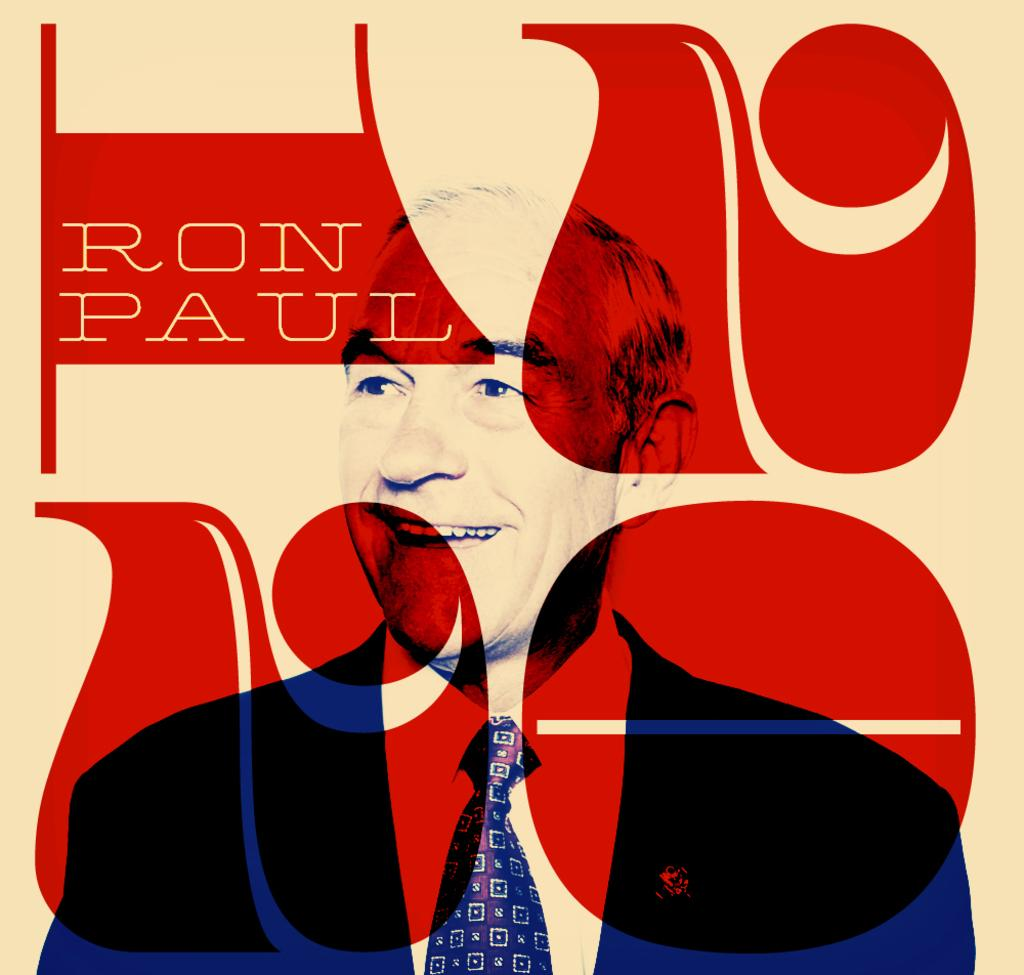Who is in the image? There is a man in the image. What is the man doing in the image? The man is smiling in the image. What else can be seen in the image besides the man? There is writing and designs present in the image. Is the man sinking in quicksand in the image? There is no quicksand present in the image, so the man is not sinking in it. 